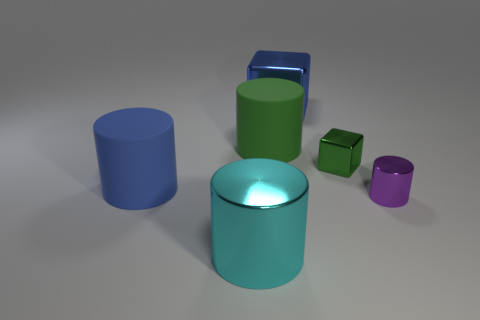Subtract 1 cylinders. How many cylinders are left? 3 Add 1 large yellow objects. How many objects exist? 7 Subtract all cylinders. How many objects are left? 2 Add 2 cyan metallic cylinders. How many cyan metallic cylinders exist? 3 Subtract 0 red balls. How many objects are left? 6 Subtract all blue metal things. Subtract all big green cylinders. How many objects are left? 4 Add 3 large cyan cylinders. How many large cyan cylinders are left? 4 